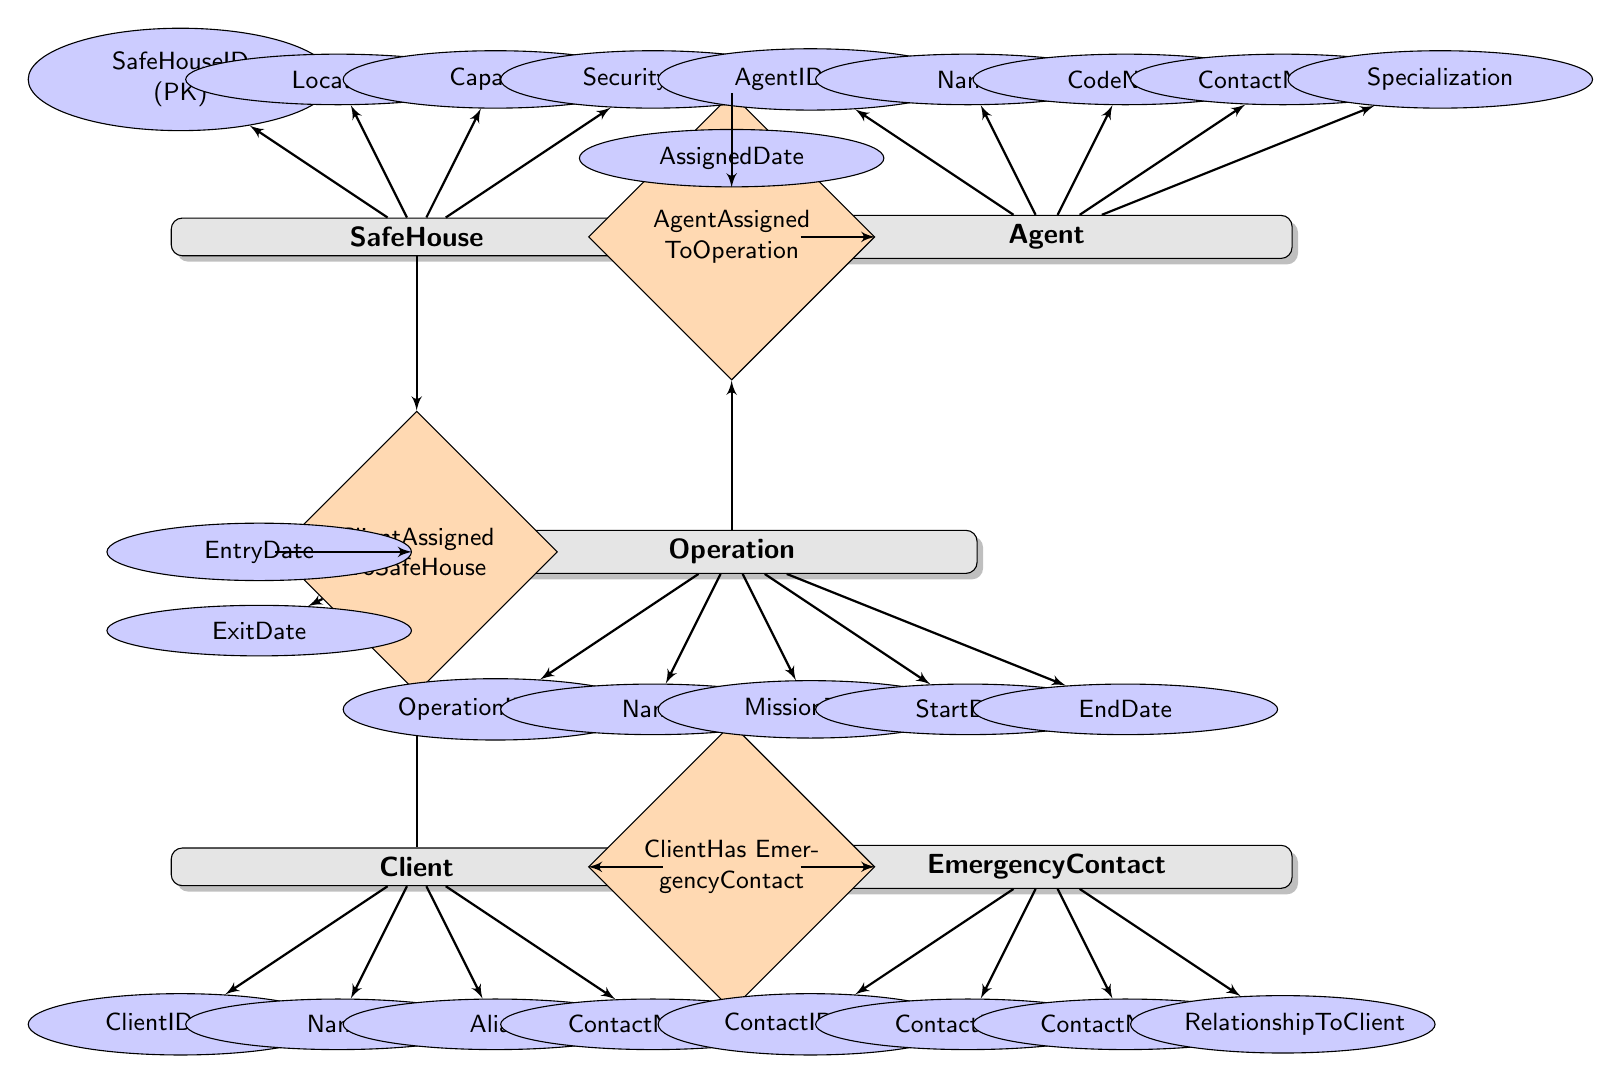What is the primary key for the SafeHouse entity? The primary key for the SafeHouse entity is listed as SafeHouseID (PK) in the attributes section connected to the SafeHouse node.
Answer: SafeHouseID How many entities are there in the diagram? The diagram lists a total of five entities: SafeHouse, Agent, Operation, Client, and EmergencyContact, indicating the scope of the system.
Answer: 5 What is the relationship between Client and EmergencyContact? The relationship is labeled as "ClientHas EmergencyContact," which connects the Client and EmergencyContact entities through this specific relationship relationship.
Answer: ClientHas EmergencyContact What attribute represents the Agent's specialization? The attribute Specialization is shown connected to the Agent entity, indicating specific skills or areas of expertise.
Answer: Specialization Which entity is associated with the EntryDate and ExitDate attributes? The Client entity is linked to the ClientAssignedToSafeHouse relationship, which has EntryDate and ExitDate as attributes associated with it.
Answer: Client How many attributes does the Operation entity contain? The Operation entity has five attributes: OperationID (PK), Name, MissionType, StartDate, and EndDate, which are all connected to it in the diagram.
Answer: 5 What does the AssignedDate attribute relate to? The AssignedDate attribute is associated with the AgentAssignedToOperation relationship, which connects the Agent and Operation entities, indicating when an agent was assigned to a specific operation.
Answer: AssignedDate Which attribute identifies the primary key for the EmergencyContact entity? The primary key for the EmergencyContact entity is identified as ContactID (PK), which ensures each contact is unique within the database.
Answer: ContactID What is indicated by the relationship ClientAssignedToSafeHouse? The relationship ClientAssignedToSafeHouse signifies the connection between Client and SafeHouse, showing which clients are assigned to which safe houses along with their respective entry and exit dates.
Answer: ClientAssignedToSafeHouse 